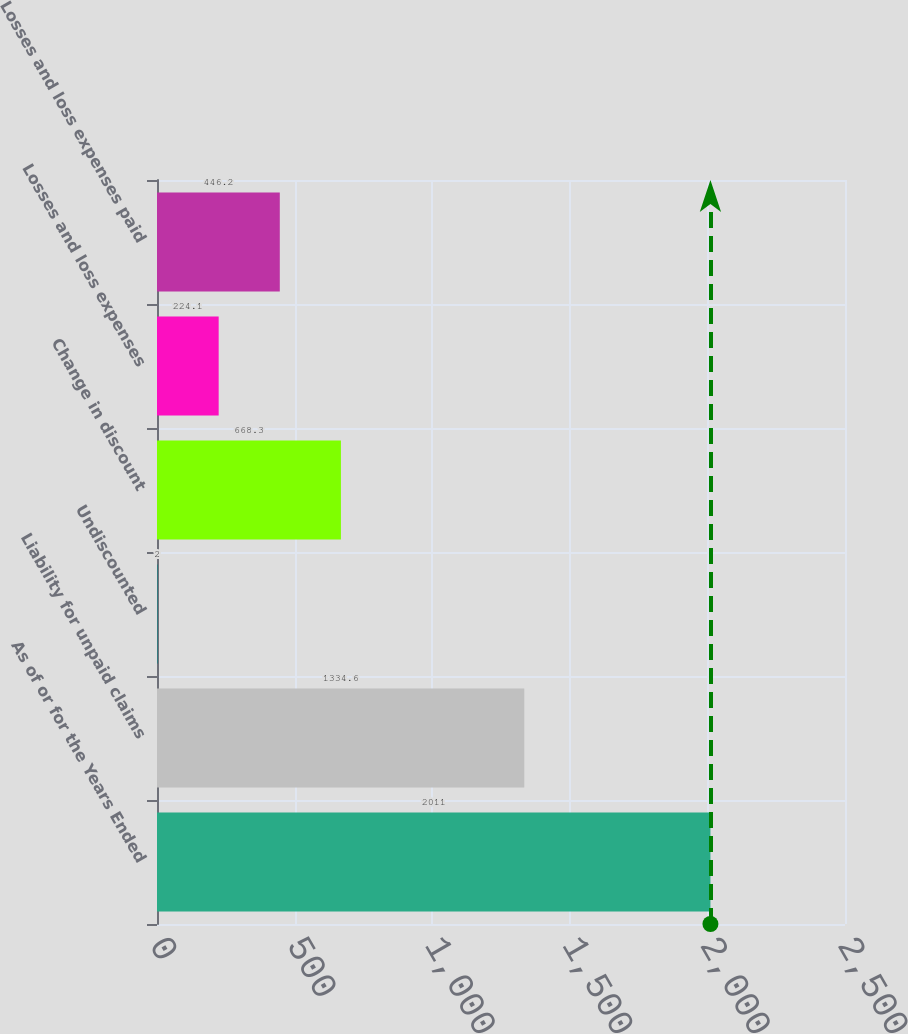Convert chart. <chart><loc_0><loc_0><loc_500><loc_500><bar_chart><fcel>As of or for the Years Ended<fcel>Liability for unpaid claims<fcel>Undiscounted<fcel>Change in discount<fcel>Losses and loss expenses<fcel>Losses and loss expenses paid<nl><fcel>2011<fcel>1334.6<fcel>2<fcel>668.3<fcel>224.1<fcel>446.2<nl></chart> 